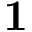Convert formula to latex. <formula><loc_0><loc_0><loc_500><loc_500>1</formula> 